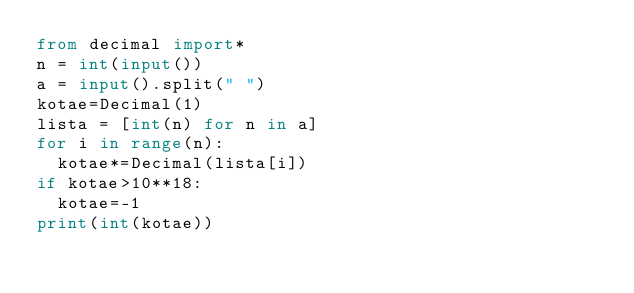Convert code to text. <code><loc_0><loc_0><loc_500><loc_500><_Python_>from decimal import*
n = int(input())
a = input().split(" ")
kotae=Decimal(1)
lista = [int(n) for n in a]
for i in range(n):
  kotae*=Decimal(lista[i])
if kotae>10**18:
  kotae=-1
print(int(kotae))
  </code> 